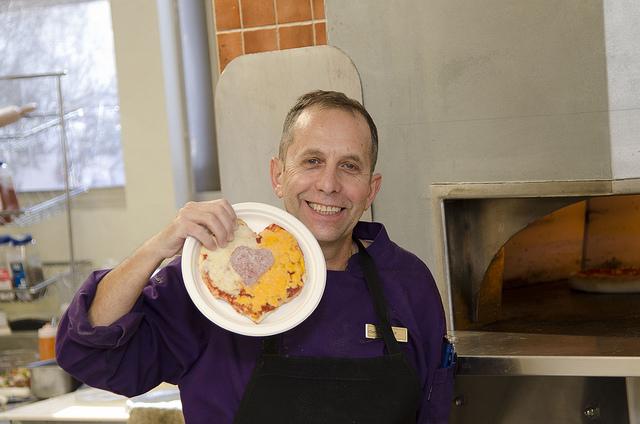Is the man wearing an apron?
Answer briefly. Yes. What shape has the man designed?
Answer briefly. Heart. Is the food stuck to the plate?
Answer briefly. No. 